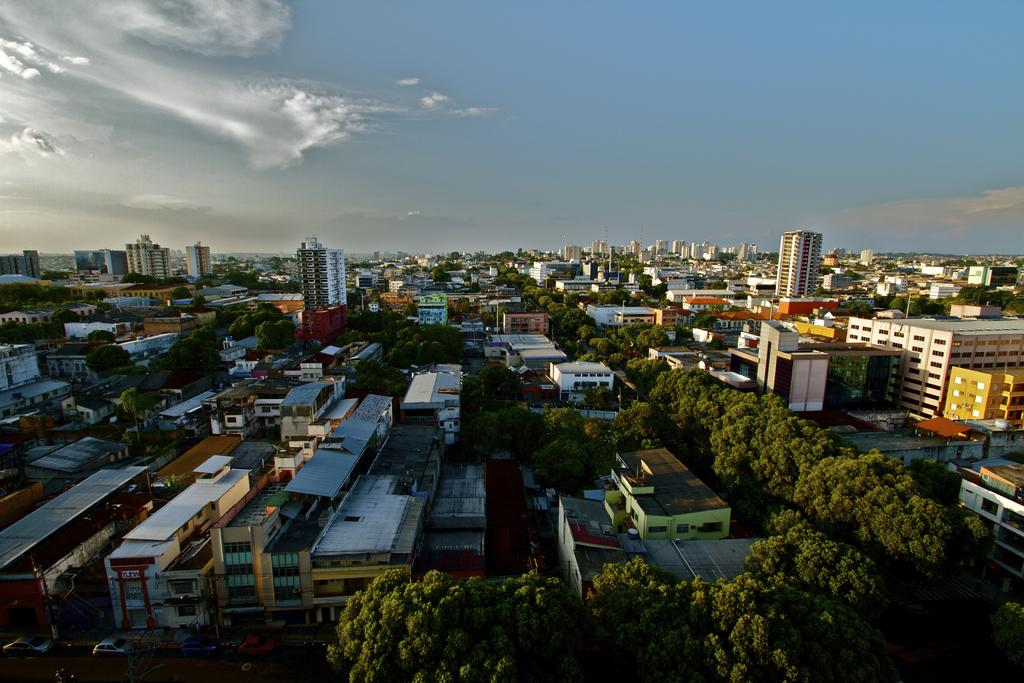What perspective is the image taken from? The image is taken from a top view. What types of structures can be seen in the image? There are many buildings in the image. What other natural elements are present in the image? There are trees in the image. What is happening on the road in the bottom left of the image? Vehicles are moving on the road in the bottom left of the image. What is visible at the top of the image? The sky is visible at the top of the image. How does the image compare to a painting of a pot? The image is not a painting of a pot; it is a photograph taken from a top view showing buildings, trees, vehicles, and the sky. 